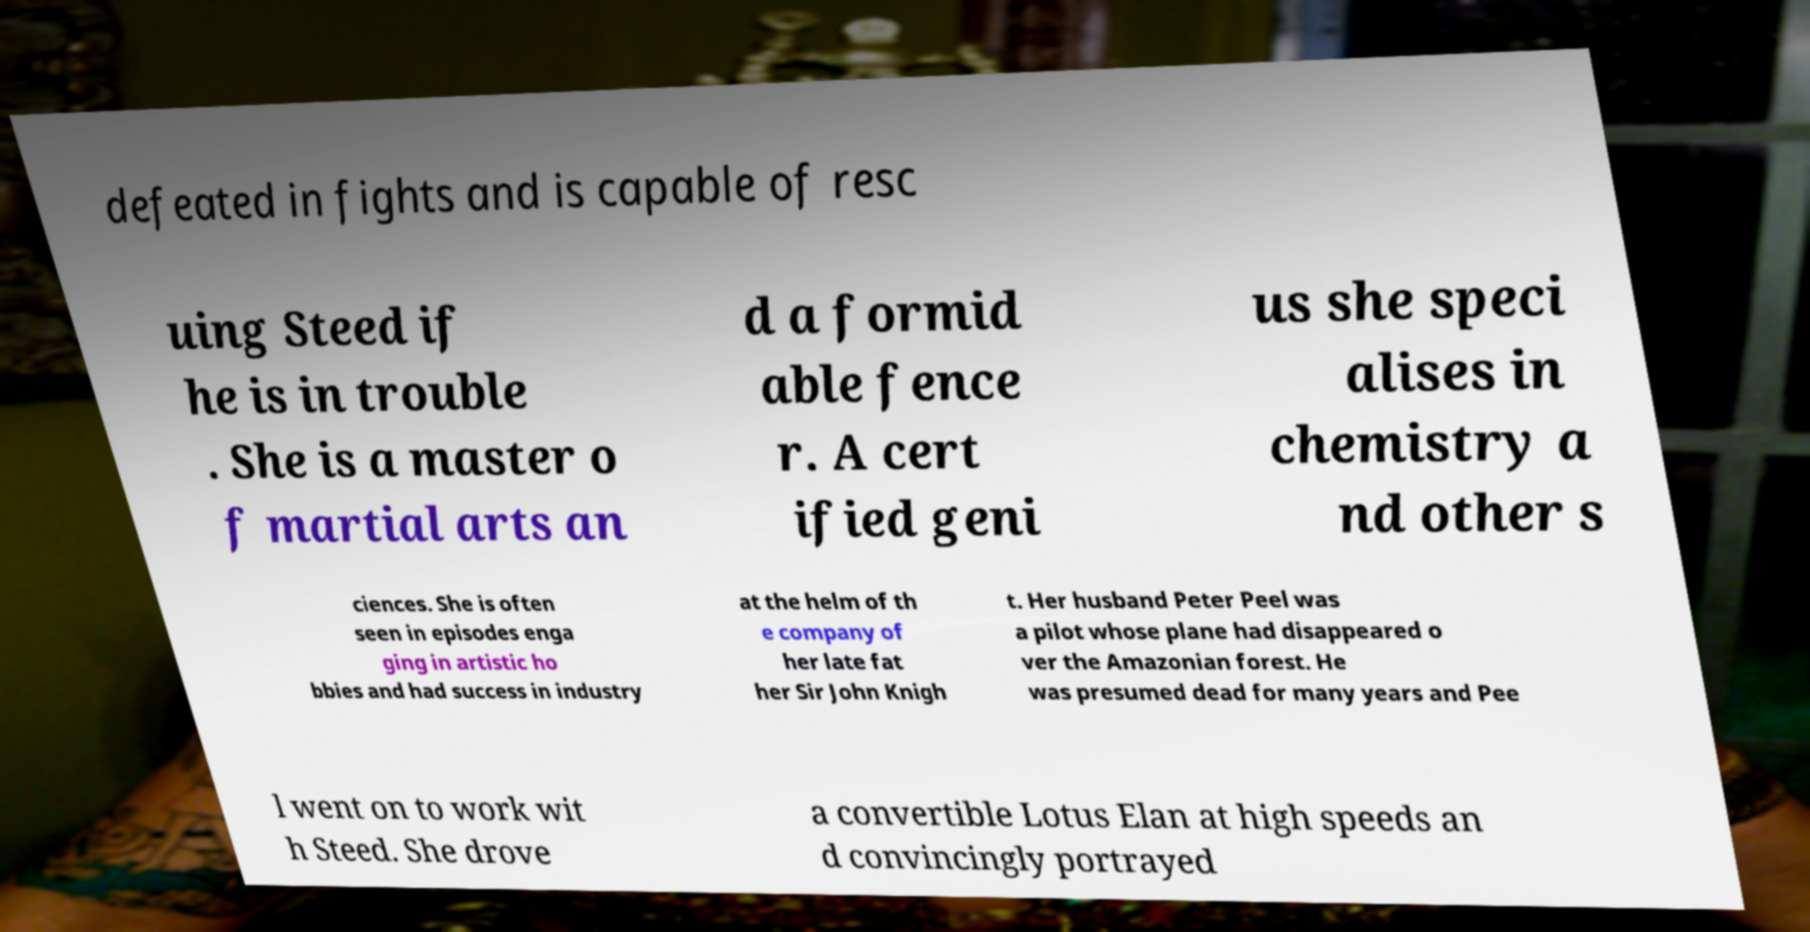Could you extract and type out the text from this image? defeated in fights and is capable of resc uing Steed if he is in trouble . She is a master o f martial arts an d a formid able fence r. A cert ified geni us she speci alises in chemistry a nd other s ciences. She is often seen in episodes enga ging in artistic ho bbies and had success in industry at the helm of th e company of her late fat her Sir John Knigh t. Her husband Peter Peel was a pilot whose plane had disappeared o ver the Amazonian forest. He was presumed dead for many years and Pee l went on to work wit h Steed. She drove a convertible Lotus Elan at high speeds an d convincingly portrayed 